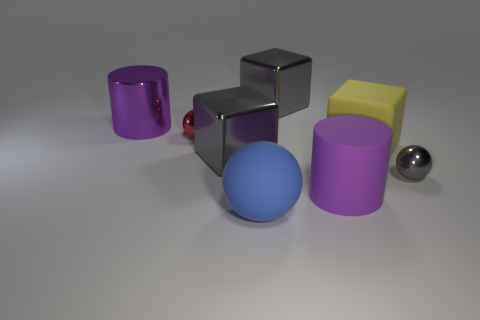Are there fewer blue matte spheres left of the big matte ball than metal cylinders?
Provide a succinct answer. Yes. There is a big yellow matte object that is behind the big shiny object in front of the large purple object that is behind the gray sphere; what shape is it?
Provide a succinct answer. Cube. Do the large yellow matte object and the large purple matte thing have the same shape?
Your answer should be very brief. No. How many other objects are the same shape as the blue object?
Your answer should be very brief. 2. What is the color of the rubber cylinder that is the same size as the purple metallic cylinder?
Your answer should be compact. Purple. Are there an equal number of large purple things that are on the left side of the red metal ball and large purple cylinders?
Provide a short and direct response. No. There is a gray thing that is in front of the purple metal object and right of the big rubber ball; what is its shape?
Make the answer very short. Sphere. Is the yellow rubber thing the same size as the red shiny ball?
Give a very brief answer. No. Are there any large purple blocks that have the same material as the tiny red thing?
Offer a very short reply. No. What is the size of the metal object that is the same color as the rubber cylinder?
Provide a succinct answer. Large. 